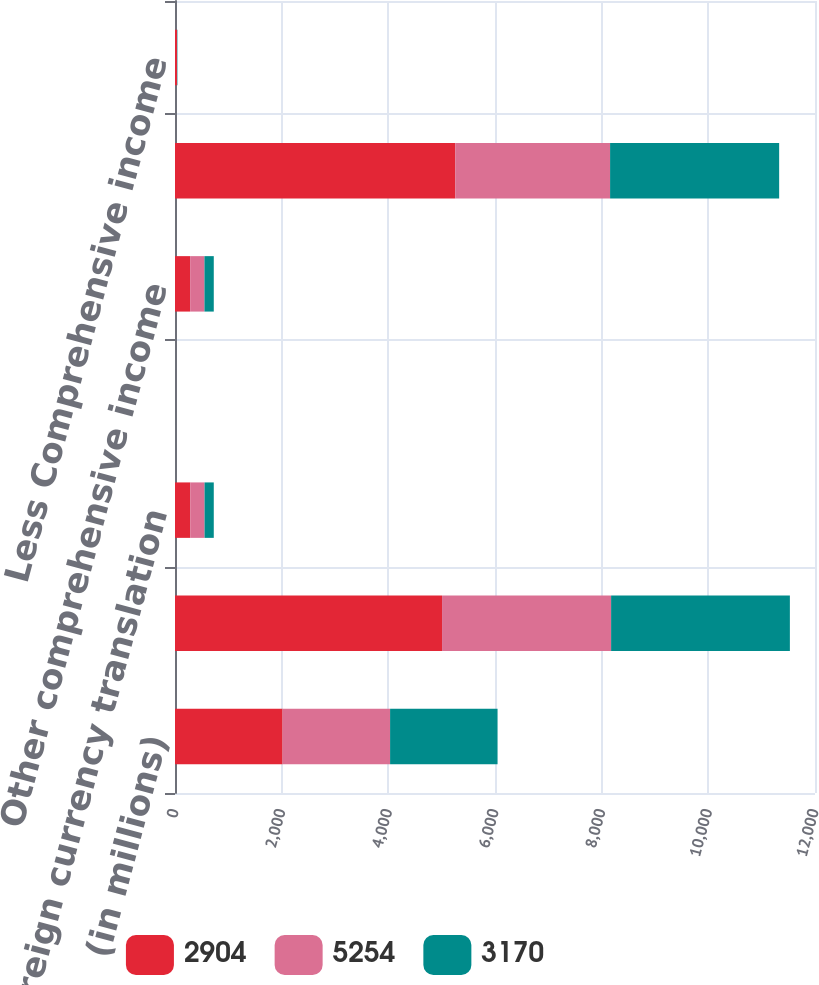Convert chart to OTSL. <chart><loc_0><loc_0><loc_500><loc_500><stacked_bar_chart><ecel><fcel>(in millions)<fcel>Net income<fcel>Foreign currency translation<fcel>Other<fcel>Other comprehensive income<fcel>Comprehensive income<fcel>Less Comprehensive income<nl><fcel>2904<fcel>2017<fcel>5007<fcel>285<fcel>1<fcel>284<fcel>5254<fcel>37<nl><fcel>5254<fcel>2016<fcel>3170<fcel>269<fcel>1<fcel>268<fcel>2904<fcel>2<nl><fcel>3170<fcel>2015<fcel>3352<fcel>173<fcel>2<fcel>175<fcel>3170<fcel>7<nl></chart> 